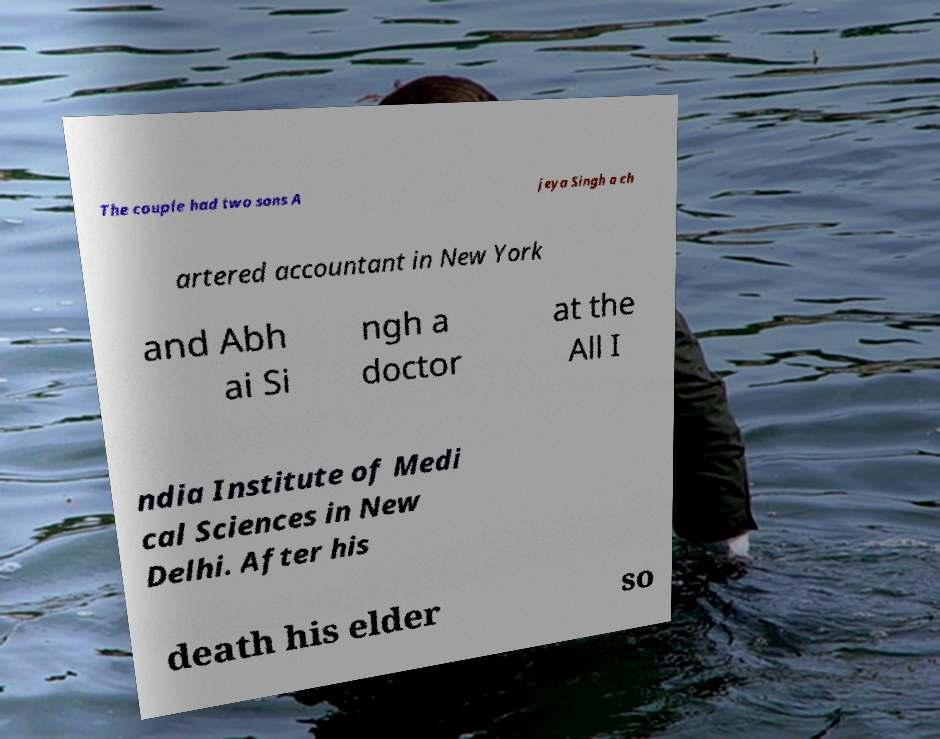Please read and relay the text visible in this image. What does it say? The couple had two sons A jeya Singh a ch artered accountant in New York and Abh ai Si ngh a doctor at the All I ndia Institute of Medi cal Sciences in New Delhi. After his death his elder so 